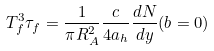<formula> <loc_0><loc_0><loc_500><loc_500>T ^ { 3 } _ { f } \tau _ { f } = \frac { 1 } { \pi R ^ { 2 } _ { A } } \frac { c } { 4 a _ { h } } \frac { d N } { d y } ( b = 0 )</formula> 